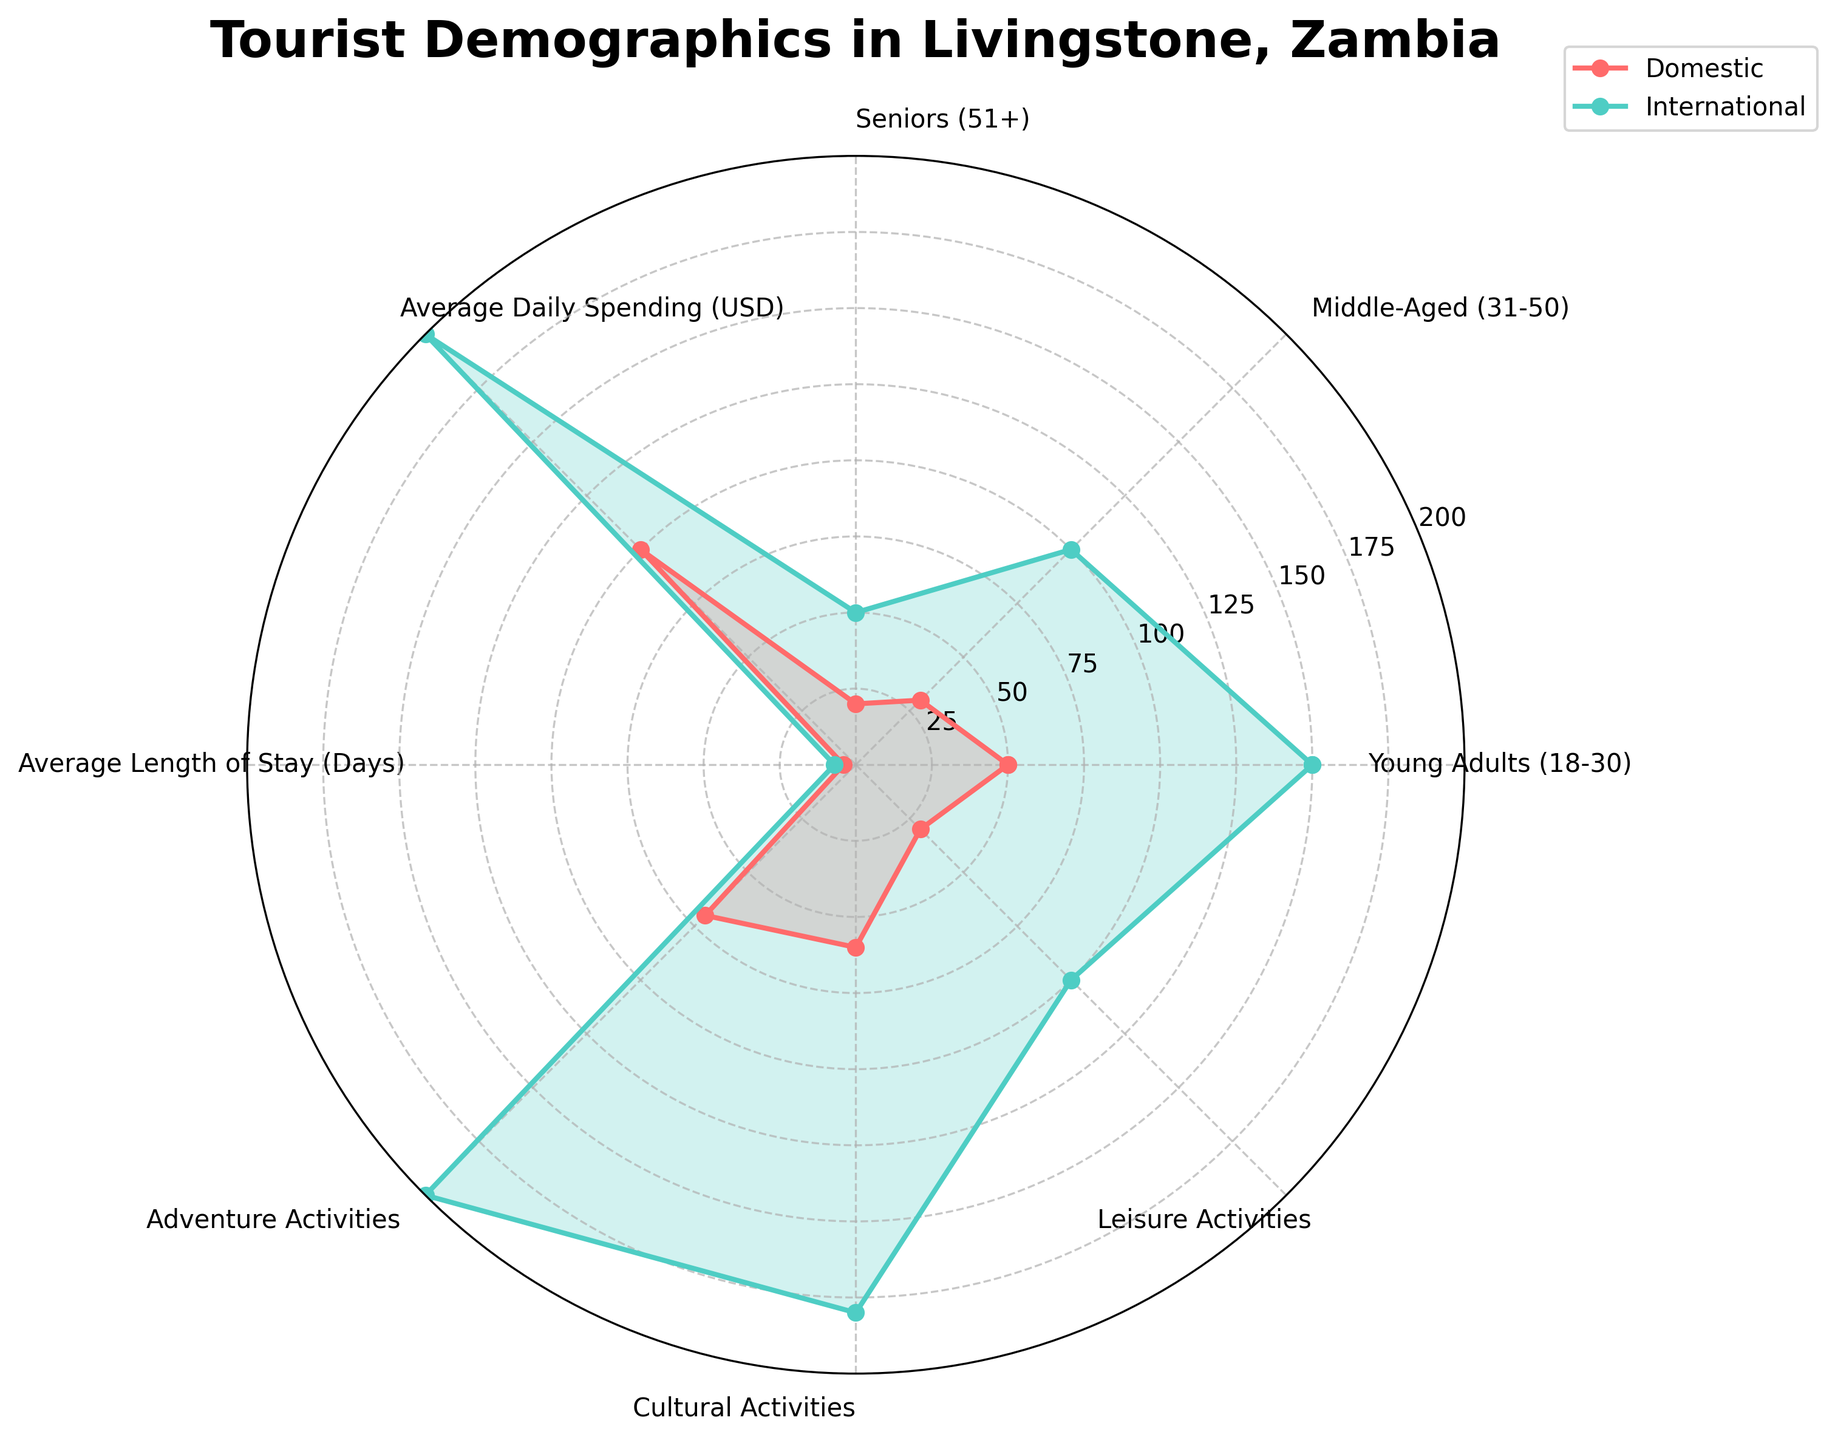What is the title of the radar chart? The title is displayed at the top center of the radar chart. Titles in charts aim to provide a brief description of what the chart represents.
Answer: Tourist Demographics in Livingstone, Zambia Which segment has a higher average daily spending, domestic or international tourists? Compare the values for "Average Daily Spending (USD)" on the radar chart for both segments. International tourists show a higher value.
Answer: International tourists What is the number of categories shown in the radar chart? Count the distinct labels (categories) along the perimeter of the radar chart. These typically include the different demographic and behavior segments of tourists.
Answer: 8 In which segment do domestic tourists have the highest value? Locate the category where the domestic tourist plot extends the furthest from the center. It's the segment with the maximum value.
Answer: Adventure Activities By how many days is the average length of stay longer for international tourists compared to domestic tourists? Subtract the average length of stay for domestic tourists from that of international tourists. Refer to the values on the radar chart.
Answer: 3 days Which type of activities do both domestic and international tourists show the least interest in? Identify the category where both plots (domestic and international) have the smallest values.
Answer: Leisure Activities Do middle-aged international tourists outnumber middle-aged domestic tourists? Compare the values for "Middle-Aged (31-50)" between domestic and international tourists.
Answer: Yes What is the difference in the number of young adult tourists (18-30) between domestic and international segments? Subtract the number of young adult domestic tourists from the number of young adult international tourists.
Answer: 100 Which category shows the least discrepancy between domestic and international tourists? Look for the category where the plot lines for domestic and international tourists are closest to each other, indicating similar values.
Answer: Seniors (51+) By how much do international tourists' average daily spending exceed that of domestic tourists? Subtract the average daily spending of domestic tourists from that of international tourists. Refer to the values shown in the chart.
Answer: $100 